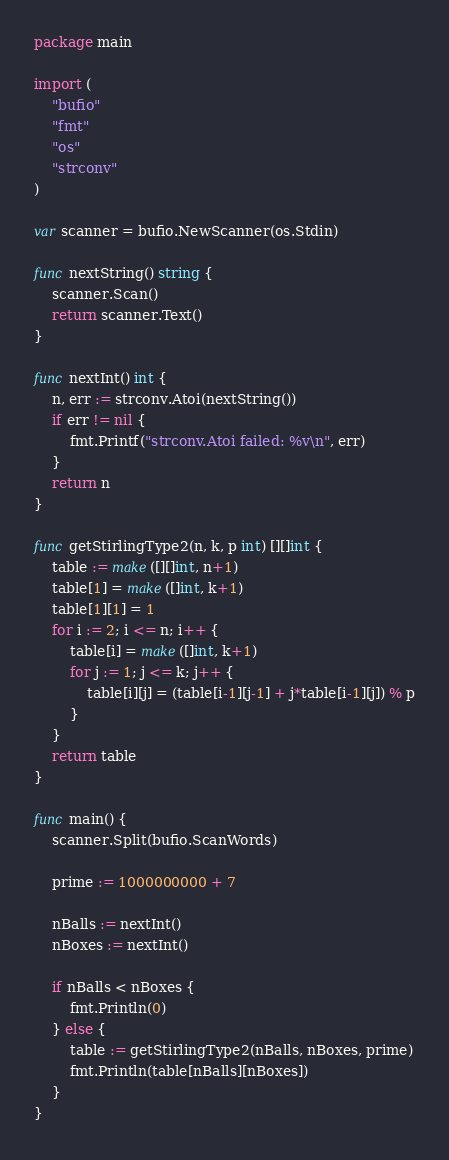<code> <loc_0><loc_0><loc_500><loc_500><_Go_>package main

import (
	"bufio"
	"fmt"
	"os"
	"strconv"
)

var scanner = bufio.NewScanner(os.Stdin)

func nextString() string {
	scanner.Scan()
	return scanner.Text()
}

func nextInt() int {
	n, err := strconv.Atoi(nextString())
	if err != nil {
		fmt.Printf("strconv.Atoi failed: %v\n", err)
	}
	return n
}

func getStirlingType2(n, k, p int) [][]int {
	table := make([][]int, n+1)
	table[1] = make([]int, k+1)
	table[1][1] = 1
	for i := 2; i <= n; i++ {
		table[i] = make([]int, k+1)
		for j := 1; j <= k; j++ {
			table[i][j] = (table[i-1][j-1] + j*table[i-1][j]) % p
		}
	}
	return table
}

func main() {
	scanner.Split(bufio.ScanWords)

	prime := 1000000000 + 7

	nBalls := nextInt()
	nBoxes := nextInt()

	if nBalls < nBoxes {
		fmt.Println(0)
	} else {
		table := getStirlingType2(nBalls, nBoxes, prime)
		fmt.Println(table[nBalls][nBoxes])
	}
}

</code> 